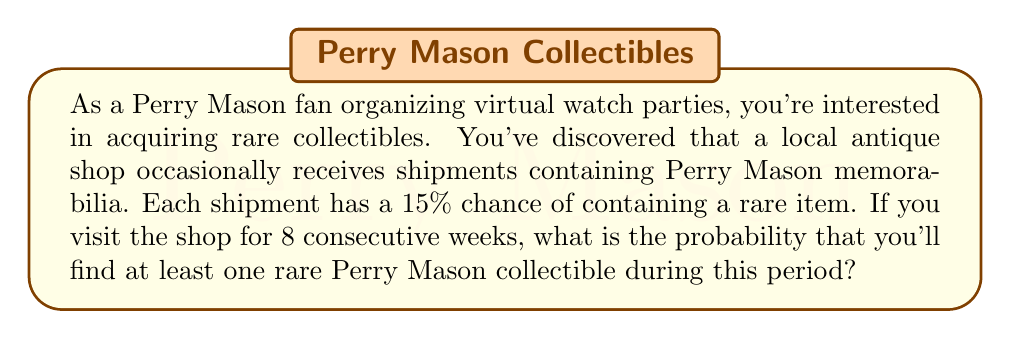Could you help me with this problem? To solve this problem, we'll use the concept of probability for independent events.

1) First, let's calculate the probability of not finding a rare item in a single visit:
   $P(\text{no rare item}) = 1 - P(\text{rare item}) = 1 - 0.15 = 0.85$

2) Since we're visiting for 8 consecutive weeks, and each visit is independent, the probability of not finding a rare item in all 8 visits is:
   $P(\text{no rare item in 8 visits}) = 0.85^8$

3) Therefore, the probability of finding at least one rare item is the complement of finding no rare items:
   $P(\text{at least one rare item}) = 1 - P(\text{no rare item in 8 visits})$

4) Let's calculate:
   $P(\text{at least one rare item}) = 1 - 0.85^8$
   $= 1 - 0.2725678$
   $\approx 0.7274322$

5) Converting to a percentage:
   $0.7274322 \times 100\% \approx 72.74\%$

Thus, the probability of finding at least one rare Perry Mason collectible in 8 weekly visits is approximately 72.74%.
Answer: $72.74\%$ 